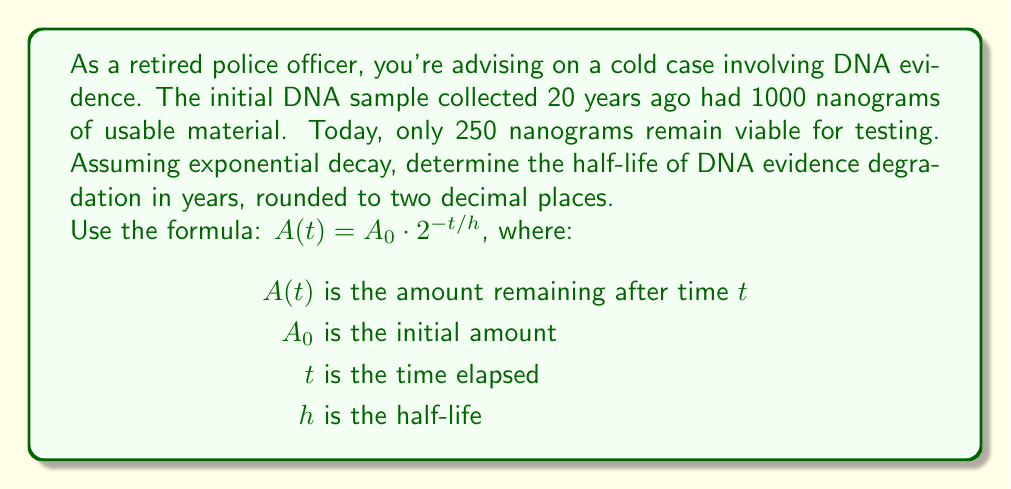Show me your answer to this math problem. Let's approach this step-by-step:

1) We're given:
   $A_0 = 1000$ nanograms (initial amount)
   $A(t) = 250$ nanograms (amount after 20 years)
   $t = 20$ years

2) We need to find $h$ (half-life) using the equation:
   $A(t) = A_0 \cdot 2^{-t/h}$

3) Substituting the known values:
   $250 = 1000 \cdot 2^{-20/h}$

4) Divide both sides by 1000:
   $\frac{1}{4} = 2^{-20/h}$

5) Take the logarithm (base 2) of both sides:
   $\log_2(\frac{1}{4}) = \log_2(2^{-20/h})$

6) Simplify the left side and use the logarithm property on the right:
   $-2 = \frac{-20}{h}$

7) Multiply both sides by $-h$:
   $2h = 20$

8) Solve for $h$:
   $h = 10$

Therefore, the half-life of DNA evidence degradation is 10 years.
Answer: 10.00 years 